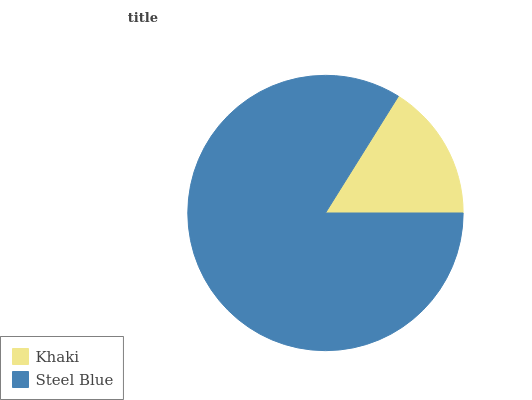Is Khaki the minimum?
Answer yes or no. Yes. Is Steel Blue the maximum?
Answer yes or no. Yes. Is Steel Blue the minimum?
Answer yes or no. No. Is Steel Blue greater than Khaki?
Answer yes or no. Yes. Is Khaki less than Steel Blue?
Answer yes or no. Yes. Is Khaki greater than Steel Blue?
Answer yes or no. No. Is Steel Blue less than Khaki?
Answer yes or no. No. Is Steel Blue the high median?
Answer yes or no. Yes. Is Khaki the low median?
Answer yes or no. Yes. Is Khaki the high median?
Answer yes or no. No. Is Steel Blue the low median?
Answer yes or no. No. 